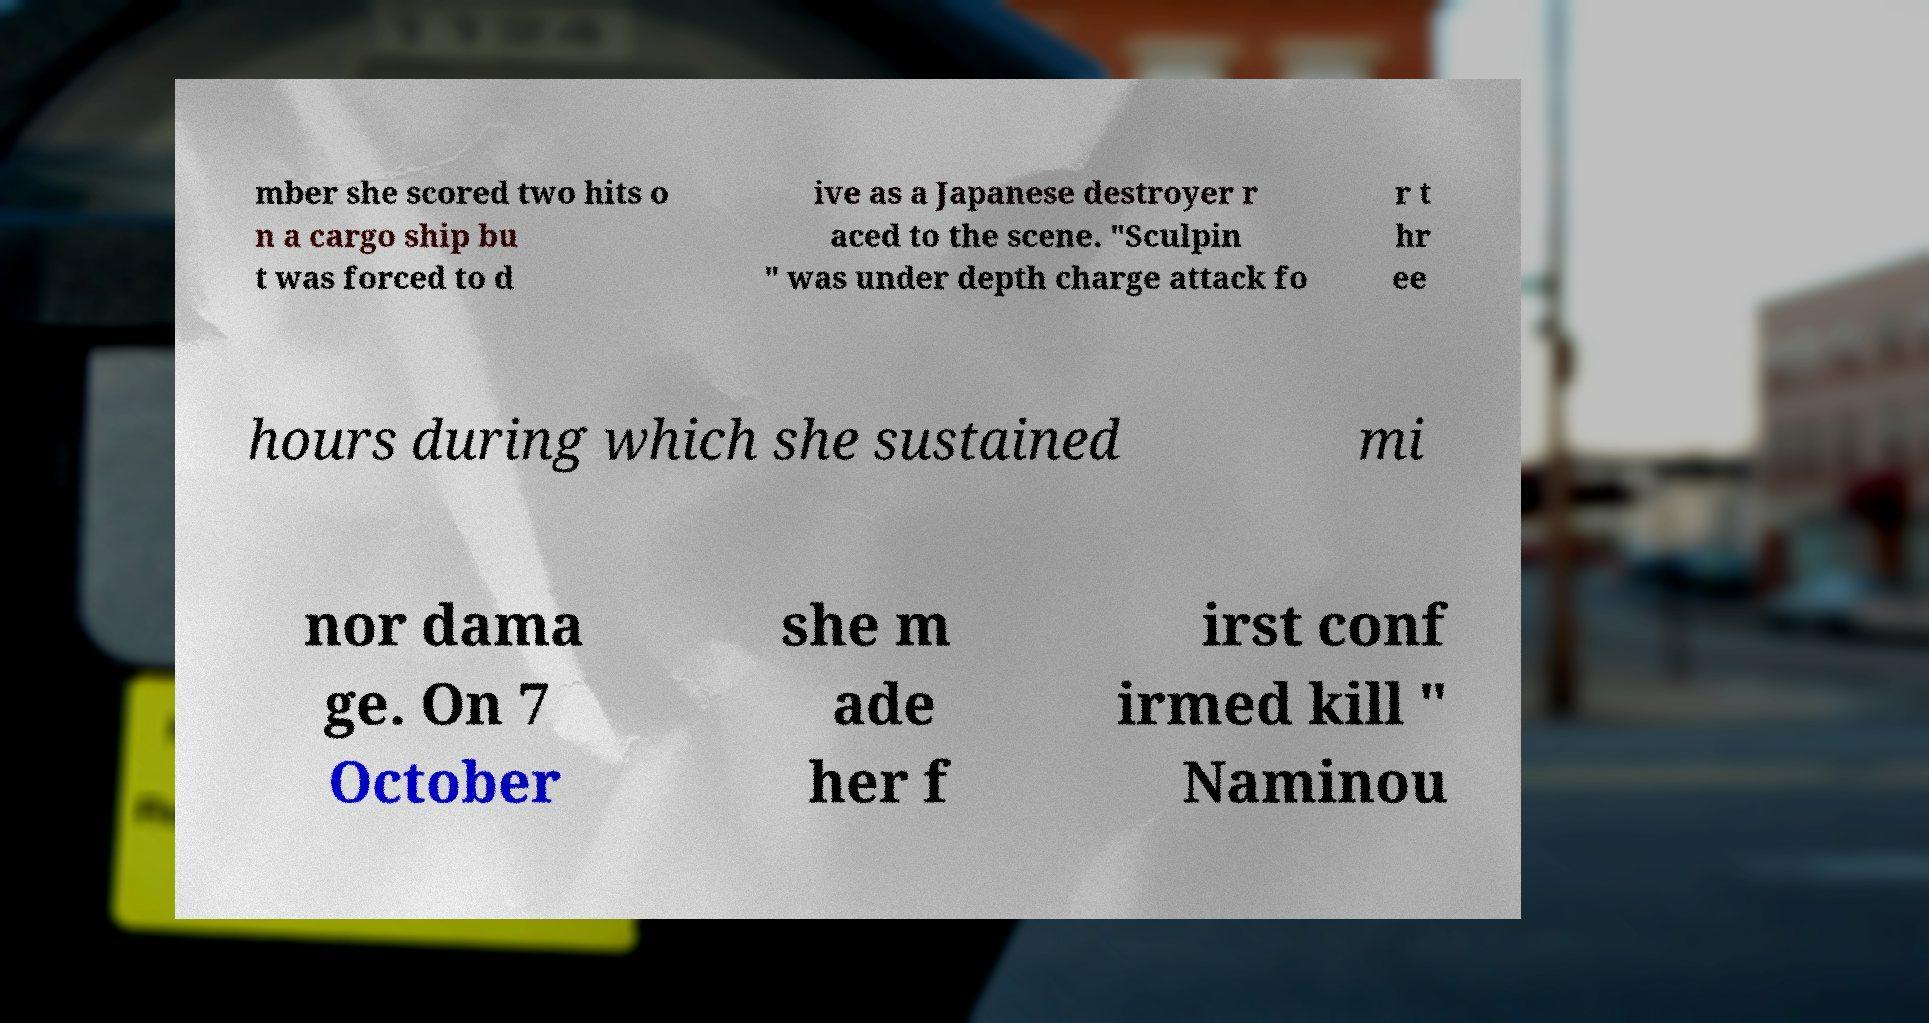I need the written content from this picture converted into text. Can you do that? mber she scored two hits o n a cargo ship bu t was forced to d ive as a Japanese destroyer r aced to the scene. "Sculpin " was under depth charge attack fo r t hr ee hours during which she sustained mi nor dama ge. On 7 October she m ade her f irst conf irmed kill " Naminou 